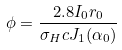<formula> <loc_0><loc_0><loc_500><loc_500>\phi = \frac { 2 . 8 I _ { 0 } r _ { 0 } } { \sigma _ { H } c J _ { 1 } ( \alpha _ { 0 } ) }</formula> 